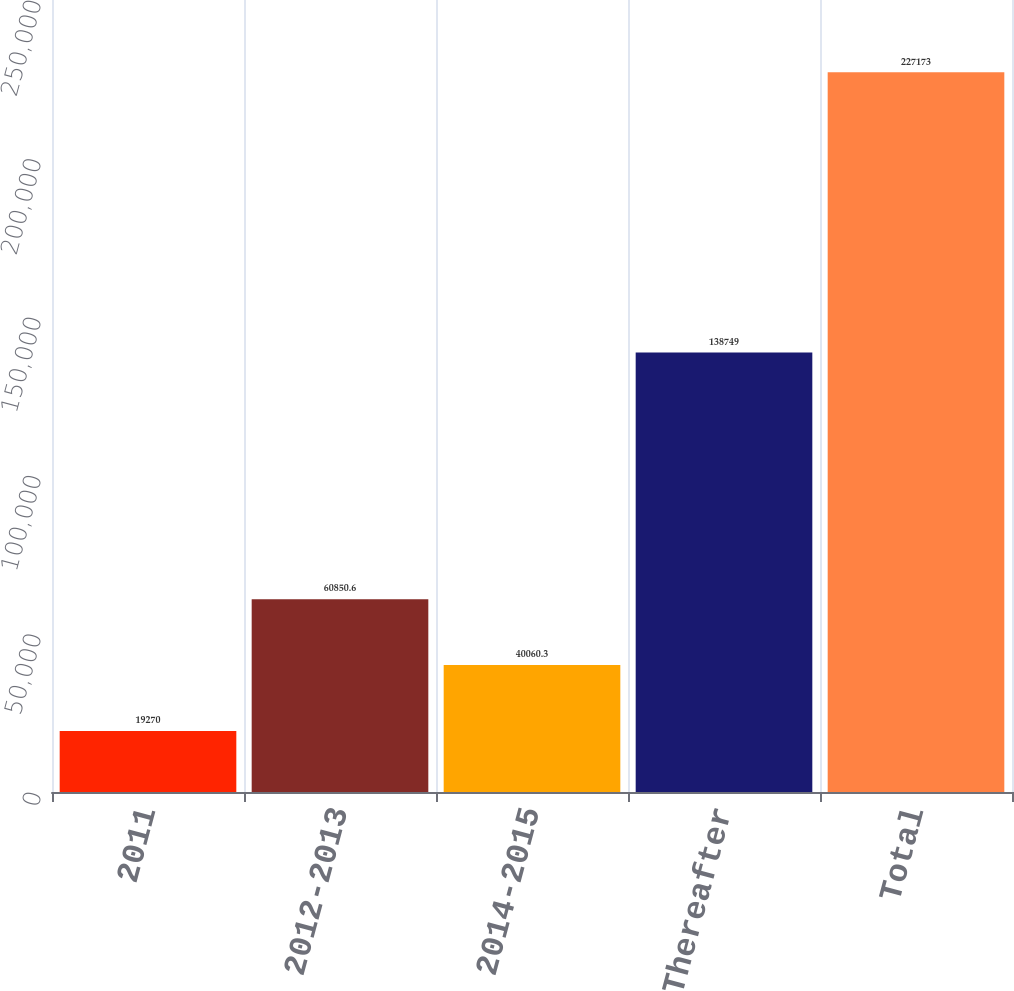Convert chart. <chart><loc_0><loc_0><loc_500><loc_500><bar_chart><fcel>2011<fcel>2012-2013<fcel>2014-2015<fcel>Thereafter<fcel>Total<nl><fcel>19270<fcel>60850.6<fcel>40060.3<fcel>138749<fcel>227173<nl></chart> 